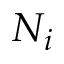<formula> <loc_0><loc_0><loc_500><loc_500>N _ { i }</formula> 